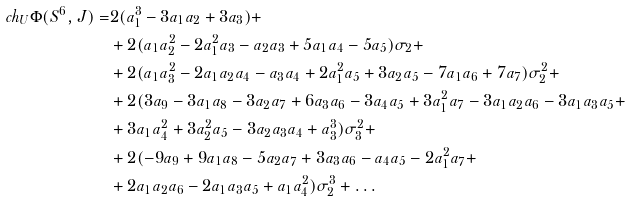<formula> <loc_0><loc_0><loc_500><loc_500>c h _ { U } \Phi ( S ^ { 6 } , J ) = & 2 ( a _ { 1 } ^ { 3 } - 3 a _ { 1 } a _ { 2 } + 3 a _ { 3 } ) + \\ & + 2 ( a _ { 1 } a _ { 2 } ^ { 2 } - 2 a _ { 1 } ^ { 2 } a _ { 3 } - a _ { 2 } a _ { 3 } + 5 a _ { 1 } a _ { 4 } - 5 a _ { 5 } ) \sigma _ { 2 } + \\ & + 2 ( a _ { 1 } a _ { 3 } ^ { 2 } - 2 a _ { 1 } a _ { 2 } a _ { 4 } - a _ { 3 } a _ { 4 } + 2 a _ { 1 } ^ { 2 } a _ { 5 } + 3 a _ { 2 } a _ { 5 } - 7 a _ { 1 } a _ { 6 } + 7 a _ { 7 } ) \sigma _ { 2 } ^ { 2 } + \\ & + 2 ( 3 a _ { 9 } - 3 a _ { 1 } a _ { 8 } - 3 a _ { 2 } a _ { 7 } + 6 a _ { 3 } a _ { 6 } - 3 a _ { 4 } a _ { 5 } + 3 a _ { 1 } ^ { 2 } a _ { 7 } - 3 a _ { 1 } a _ { 2 } a _ { 6 } - 3 a _ { 1 } a _ { 3 } a _ { 5 } + \\ & + 3 a _ { 1 } a _ { 4 } ^ { 2 } + 3 a _ { 2 } ^ { 2 } a _ { 5 } - 3 a _ { 2 } a _ { 3 } a _ { 4 } + a _ { 3 } ^ { 3 } ) \sigma _ { 3 } ^ { 2 } + \\ & + 2 ( - 9 a _ { 9 } + 9 a _ { 1 } a _ { 8 } - 5 a _ { 2 } a _ { 7 } + 3 a _ { 3 } a _ { 6 } - a _ { 4 } a _ { 5 } - 2 a _ { 1 } ^ { 2 } a _ { 7 } + \\ & + 2 a _ { 1 } a _ { 2 } a _ { 6 } - 2 a _ { 1 } a _ { 3 } a _ { 5 } + a _ { 1 } a _ { 4 } ^ { 2 } ) \sigma _ { 2 } ^ { 3 } + \dots</formula> 